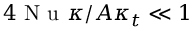Convert formula to latex. <formula><loc_0><loc_0><loc_500><loc_500>4 N u \kappa / A \kappa _ { t } \ll 1</formula> 